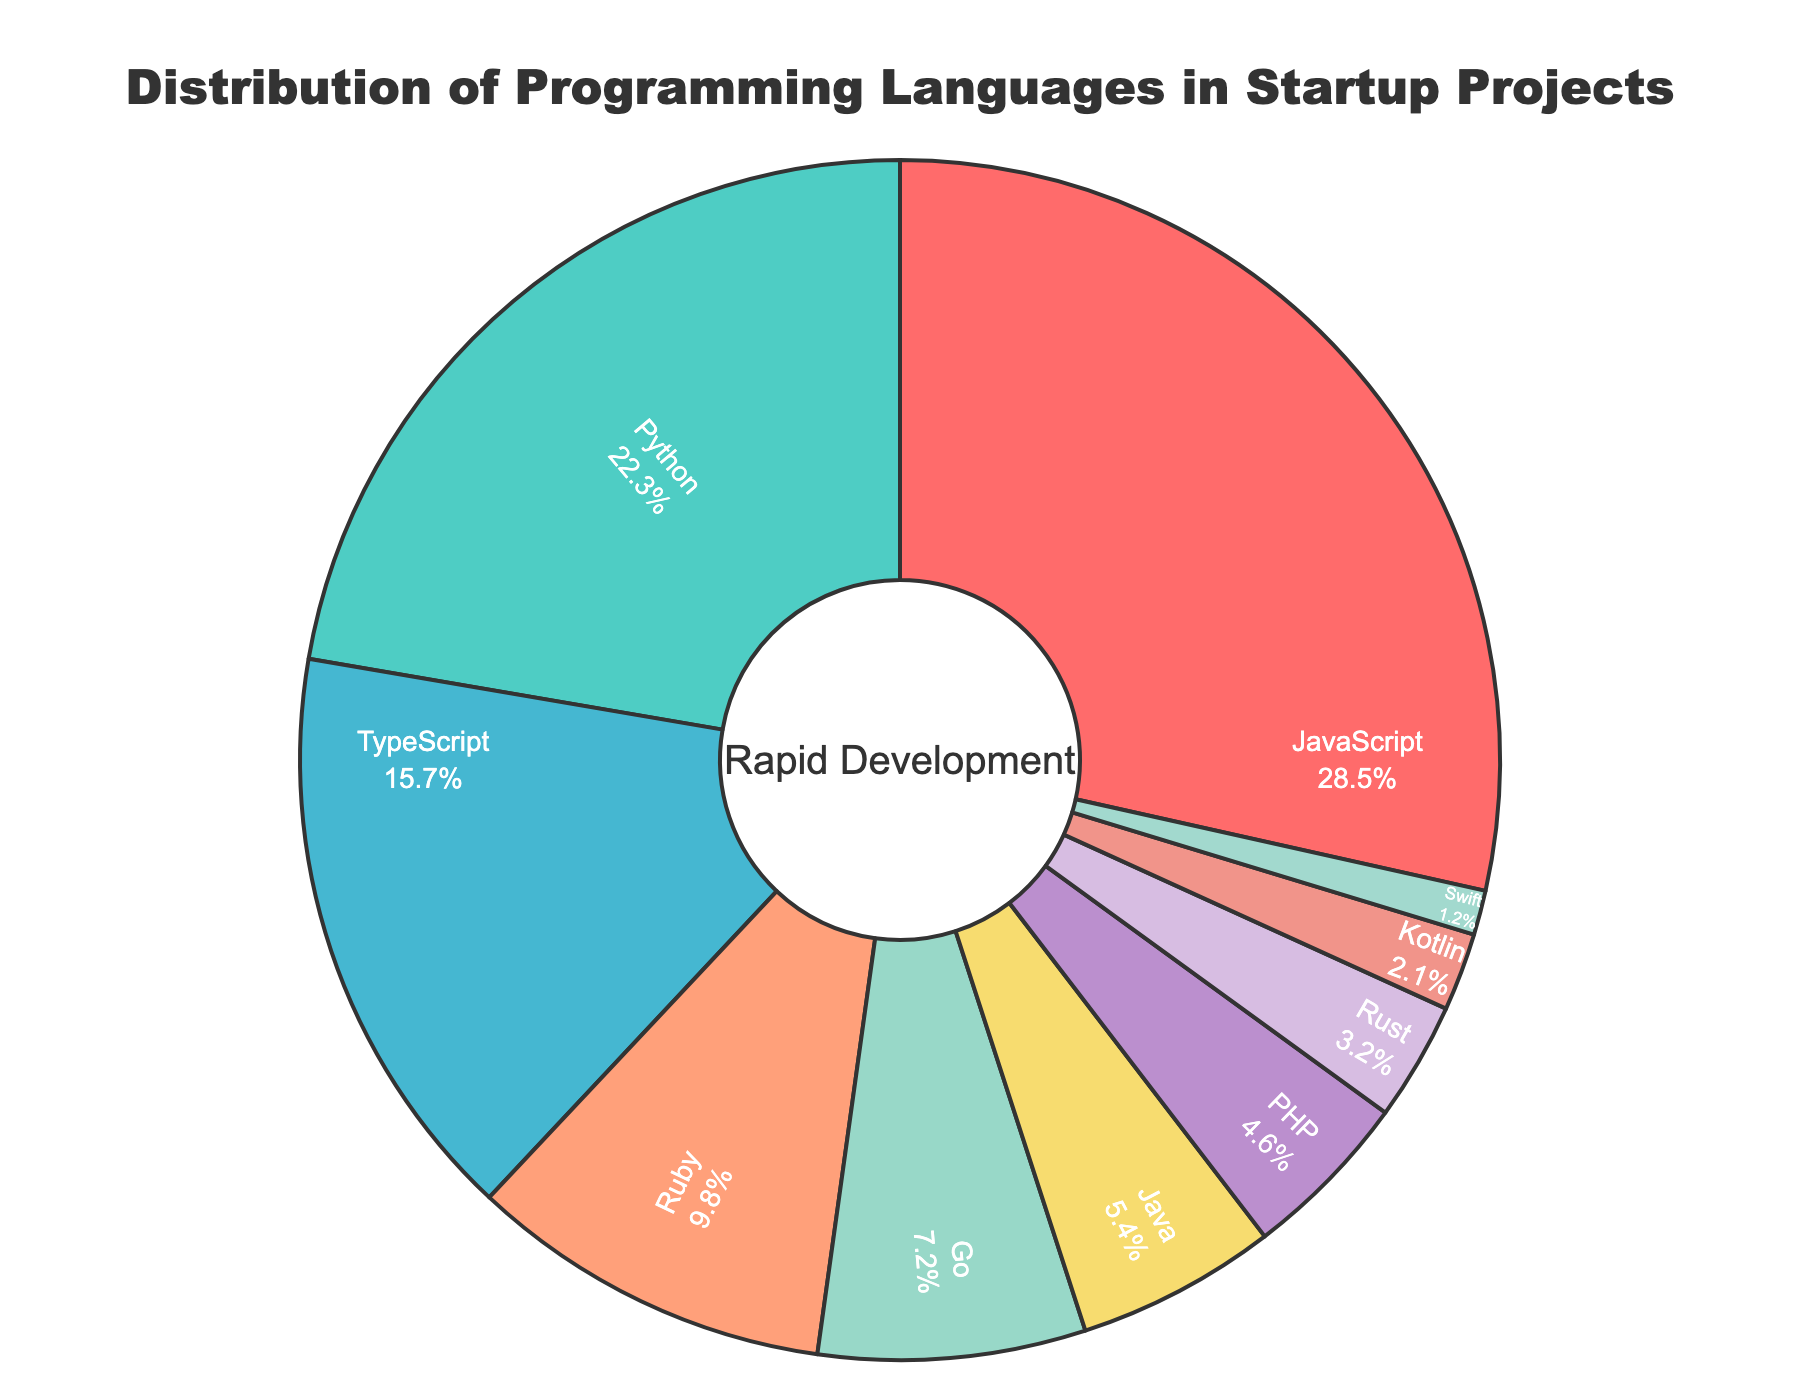Which language has the highest percentage in startup projects? Look at the segment with the largest area and identify its label. JavaScript has the largest segment with 28.5%.
Answer: JavaScript Which language has the lowest usage percentage? Find the segment with the smallest area and check its label. The smallest segment is labeled Swift, which has 1.2%.
Answer: Swift How much more popular is JavaScript compared to TypeScript? Subtract the percentage of TypeScript from the percentage of JavaScript. JavaScript is 28.5% and TypeScript is 15.7%, so 28.5 - 15.7 = 12.8%.
Answer: 12.8% What is the combined percentage of Python, Ruby, and Go? Sum the percentages of Python, Ruby, and Go. Python is 22.3%, Ruby is 9.8%, and Go is 7.2%. So, 22.3 + 9.8 + 7.2 = 39.3%.
Answer: 39.3% Which has a larger share, Java or PHP? Compare the percentages for Java and PHP. Java is 5.4% and PHP is 4.6%. Java (5.4%) is larger than PHP (4.6%).
Answer: Java What is the total percentage represented by Rust, Kotlin, and Swift? Add up the percentages of Rust, Kotlin, and Swift. Rust is 3.2%, Kotlin is 2.1%, and Swift is 1.2%. So, 3.2 + 2.1 + 1.2 = 6.5%.
Answer: 6.5% Is TypeScript usage higher or lower than Ruby usage? Compare the percentages of TypeScript and Ruby. TypeScript is 15.7% while Ruby is 9.8%, so TypeScript is higher.
Answer: Higher Which language represents a percentage close to 10%? Identify any segment that has a percentage near 10%. Ruby is at 9.8%, which is close to 10%.
Answer: Ruby How much more popular is Python compared to Go and Kotlin combined? First, add the percentages of Go and Kotlin, then subtract this sum from the percentage of Python. Go is 7.2%, Kotlin is 2.1%, so 7.2 + 2.1 = 9.3%. Then, 22.3 - 9.3 = 13%.
Answer: 13% What percentage of languages are used less than Rust? Identify the languages with percentages less than Rust (3.2%) and sum their percentages. Kotlin is 2.1% and Swift is 1.2%. So, 2.1 + 1.2 = 3.3%.
Answer: 3.3% 